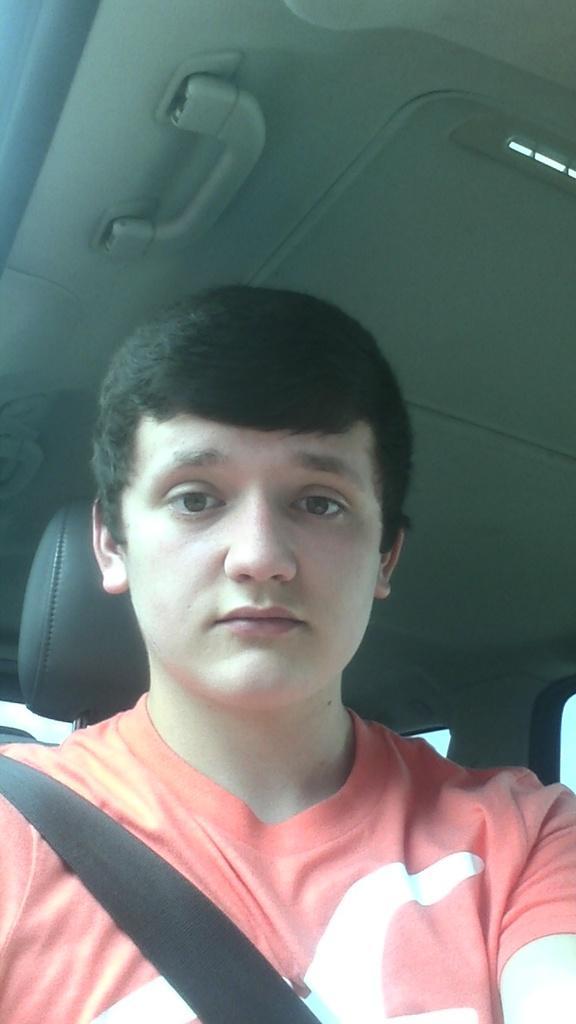Please provide a concise description of this image. In this image, we can see a person sitting in a vehicle. We can also see the roof of a vehicle. 